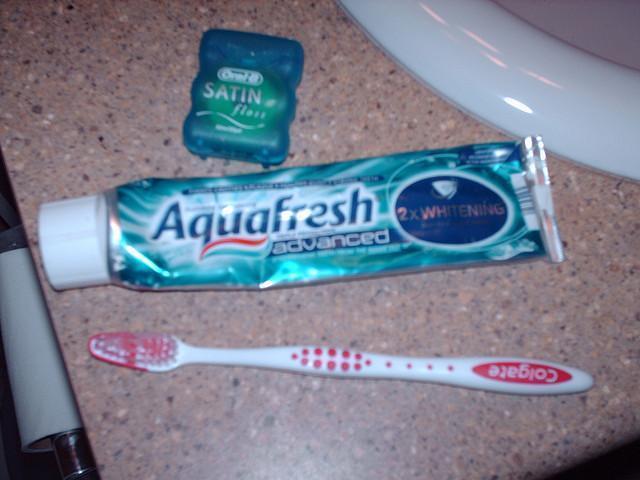How many manual toothbrushes?
Give a very brief answer. 1. How many brushes do you see?
Give a very brief answer. 1. How many toothbrushes are there?
Give a very brief answer. 1. How many toothbrushes are in the photo?
Give a very brief answer. 1. 